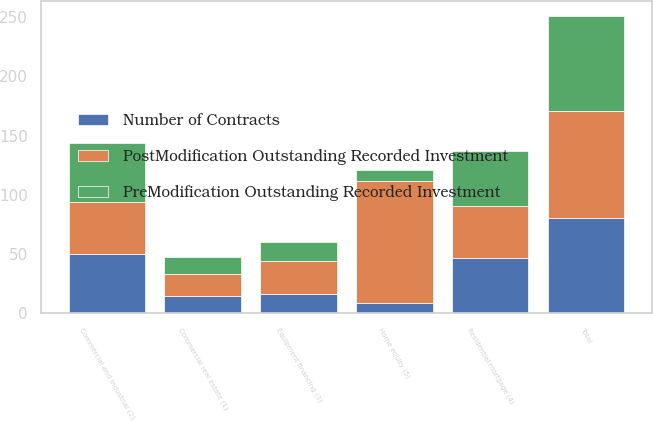<chart> <loc_0><loc_0><loc_500><loc_500><stacked_bar_chart><ecel><fcel>Commercial real estate (1)<fcel>Commercial and industrial (2)<fcel>Equipment financing (3)<fcel>Total<fcel>Residential mortgage (4)<fcel>Home equity (5)<nl><fcel>PostModification Outstanding Recorded Investment<fcel>19<fcel>44<fcel>28<fcel>91<fcel>44<fcel>103<nl><fcel>Number of Contracts<fcel>14.2<fcel>50.1<fcel>15.9<fcel>80.2<fcel>46.4<fcel>8.8<nl><fcel>PreModification Outstanding Recorded Investment<fcel>14.2<fcel>50.1<fcel>15.9<fcel>80.2<fcel>46.4<fcel>8.8<nl></chart> 